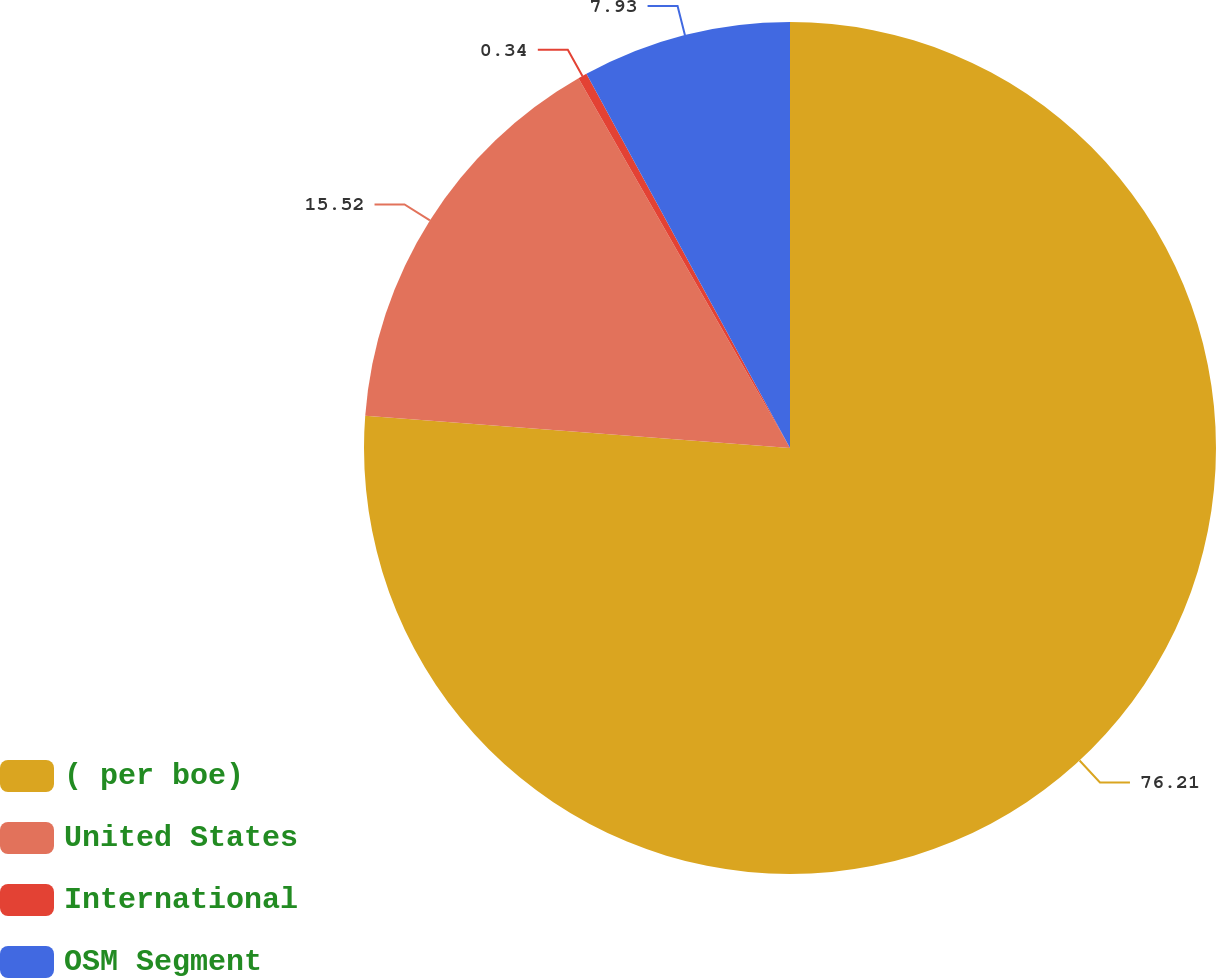Convert chart to OTSL. <chart><loc_0><loc_0><loc_500><loc_500><pie_chart><fcel>( per boe)<fcel>United States<fcel>International<fcel>OSM Segment<nl><fcel>76.21%<fcel>15.52%<fcel>0.34%<fcel>7.93%<nl></chart> 